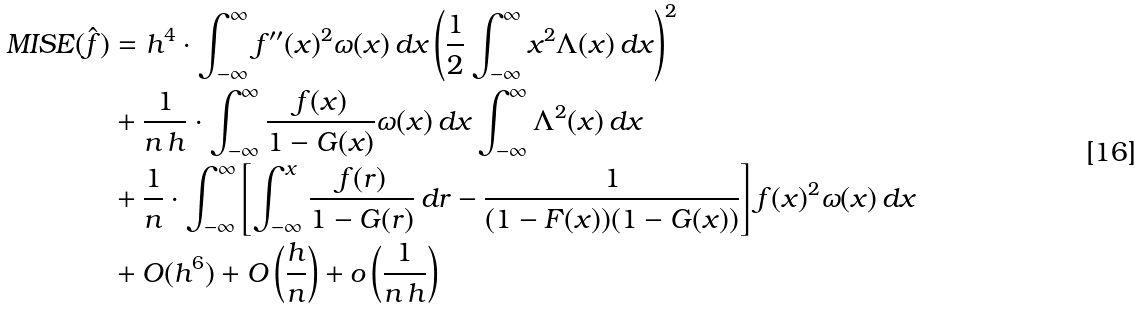<formula> <loc_0><loc_0><loc_500><loc_500>M I S E ( \hat { f } ) & = h ^ { 4 } \cdot \int _ { - \infty } ^ { \infty } f ^ { \prime \prime } ( x ) ^ { 2 } \omega ( x ) \, d x \left ( \frac { 1 } { 2 } \int _ { - \infty } ^ { \infty } x ^ { 2 } \Lambda ( x ) \, d x \right ) ^ { 2 } \\ & + \frac { 1 } { n \, h } \cdot \int _ { - \infty } ^ { \infty } \frac { f ( x ) } { 1 - G ( x ) } \omega ( x ) \, d x \int _ { - \infty } ^ { \infty } \Lambda ^ { 2 } ( x ) \, d x \\ & + \frac { 1 } { n } \cdot \int _ { - \infty } ^ { \infty } \left [ \int _ { - \infty } ^ { x } \frac { f ( r ) } { 1 - G ( r ) } \, d r - \frac { 1 } { ( 1 - F ( x ) ) ( 1 - G ( x ) ) } \right ] f ( x ) ^ { 2 } \omega ( x ) \, d x \\ & + O ( h ^ { 6 } ) + O \left ( \frac { h } { n } \right ) + o \left ( \frac { 1 } { n \, h } \right )</formula> 